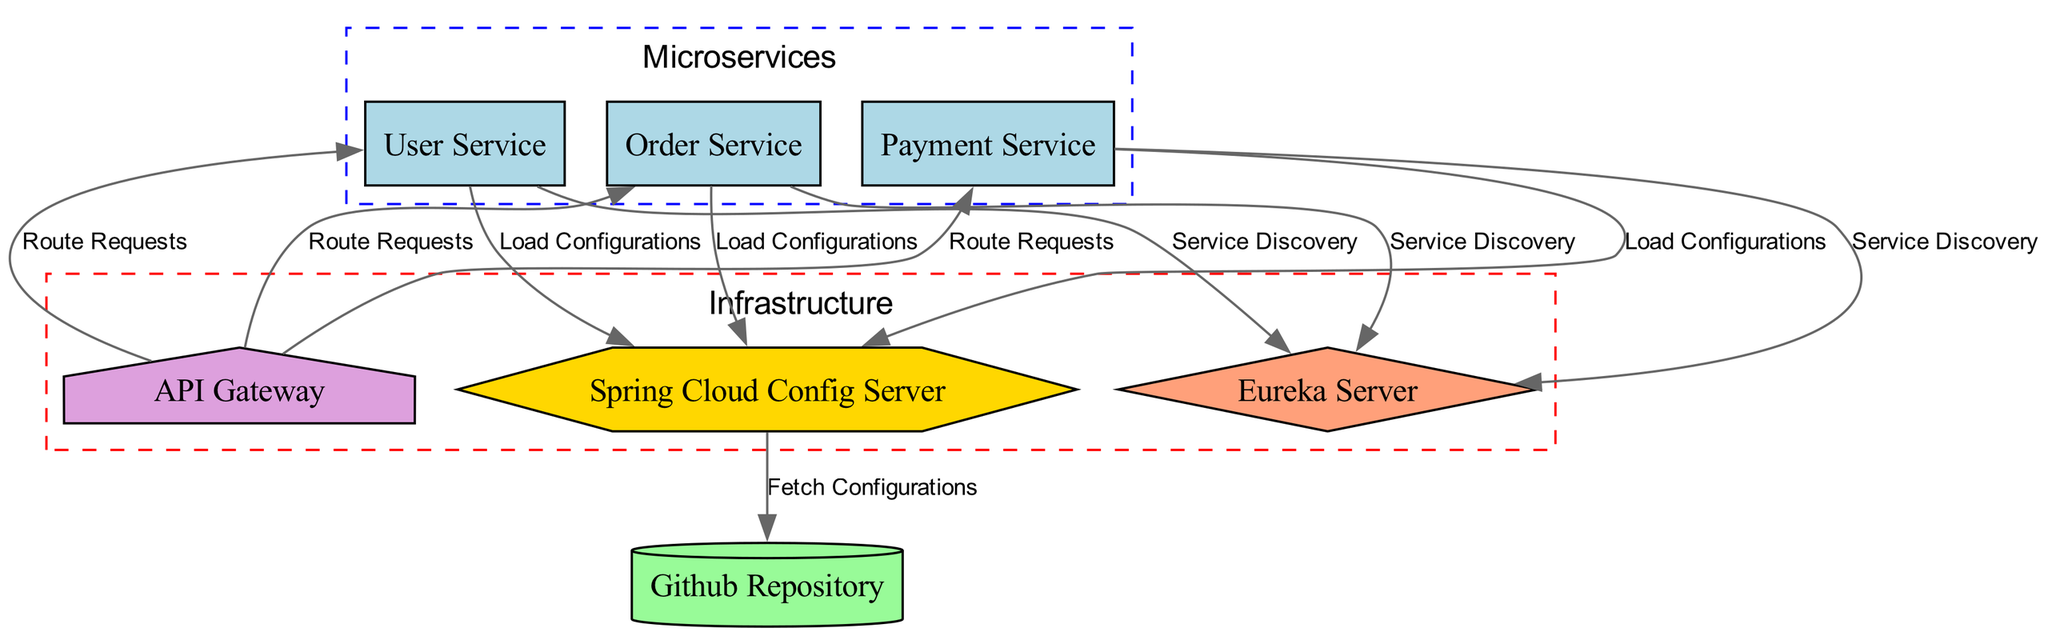What is the total number of microservices in the diagram? The diagram provides information about three distinct microservices: User Service, Order Service, and Payment Service. Counting these nodes gives a total of three microservices.
Answer: 3 Which microservice communicates with the API Gateway? The API Gateway is shown to route requests to all three microservices: User Service, Order Service, and Payment Service. Each of these microservices is directly connected to the API Gateway in the diagram.
Answer: User Service, Order Service, Payment Service What type of server is the Spring Cloud Config Server? The diagram indicates the Spring Cloud Config Server as a server type by its node shape and color, which is specified as a hexagon filled with gold color. This confirms its designation as a server.
Answer: server How many edges are there connecting the microservices to the discovery server? The diagram illustrates three connection edges from the three microservices (User Service, Order Service, Payment Service) to the discovery server for service discovery. Therefore, the count of these edges is three.
Answer: 3 What is the purpose of the connection between the Config Server and the Github Repository? The diagram specifies that the connection from the Config Server to the Github Repository is labeled "Fetch Configurations," highlighting that this is the action taken by the Config Server to retrieve configuration data from Github.
Answer: Fetch Configurations Which node has the label indicating it loads configurations? The diagram indicates that all three microservices (User Service, Order Service, Payment Service) are labeled with connections to the Config Server for loading configurations. Therefore, the answer includes these three nodes.
Answer: User Service, Order Service, Payment Service What color represents the microservices in the diagram? The microservices are represented by a light blue fill color in their node styling. This color visually distinguishes the microservices from other components in the diagram.
Answer: light blue What is the purpose of the API Gateway in relation to the microservices? The API Gateway's connections to the microservices are labeled "Route Requests," indicating that its primary purpose is to handle and direct incoming requests to the appropriate microservice as indicated in the diagram.
Answer: Route Requests 